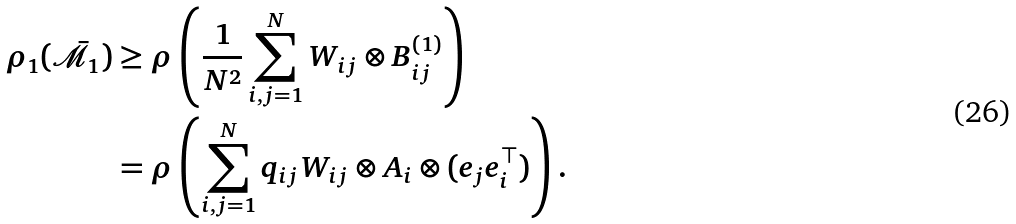<formula> <loc_0><loc_0><loc_500><loc_500>\rho _ { 1 } ( \bar { \mathcal { M } } _ { 1 } ) & \geq \rho \left ( \frac { 1 } { N ^ { 2 } } \sum _ { i , j = 1 } ^ { N } W _ { i j } \otimes B _ { i j } ^ { ( 1 ) } \right ) \\ & = \rho \left ( \sum _ { i , j = 1 } ^ { N } q _ { i j } W _ { i j } \otimes A _ { i } \otimes ( e _ { j } e _ { i } ^ { \top } ) \right ) .</formula> 